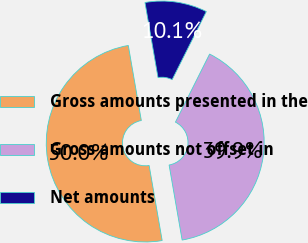Convert chart. <chart><loc_0><loc_0><loc_500><loc_500><pie_chart><fcel>Gross amounts presented in the<fcel>Gross amounts not offset in<fcel>Net amounts<nl><fcel>50.0%<fcel>39.86%<fcel>10.14%<nl></chart> 